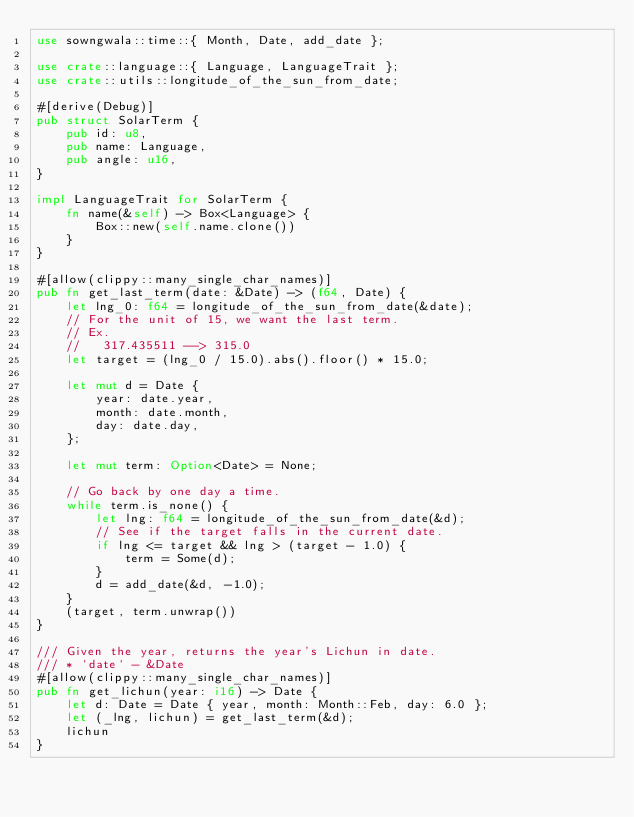Convert code to text. <code><loc_0><loc_0><loc_500><loc_500><_Rust_>use sowngwala::time::{ Month, Date, add_date };

use crate::language::{ Language, LanguageTrait };
use crate::utils::longitude_of_the_sun_from_date;

#[derive(Debug)]
pub struct SolarTerm {
    pub id: u8,
    pub name: Language,
    pub angle: u16,
}

impl LanguageTrait for SolarTerm {
    fn name(&self) -> Box<Language> {
        Box::new(self.name.clone())
    }
}

#[allow(clippy::many_single_char_names)]
pub fn get_last_term(date: &Date) -> (f64, Date) {
    let lng_0: f64 = longitude_of_the_sun_from_date(&date);
    // For the unit of 15, we want the last term.
    // Ex.
    //   317.435511 --> 315.0
    let target = (lng_0 / 15.0).abs().floor() * 15.0;

    let mut d = Date {
        year: date.year,
        month: date.month,
        day: date.day,
    };

    let mut term: Option<Date> = None;

    // Go back by one day a time.
    while term.is_none() {
        let lng: f64 = longitude_of_the_sun_from_date(&d);
        // See if the target falls in the current date.
        if lng <= target && lng > (target - 1.0) {
            term = Some(d);
        }
        d = add_date(&d, -1.0);
    }
    (target, term.unwrap())
}

/// Given the year, returns the year's Lichun in date.
/// * `date` - &Date
#[allow(clippy::many_single_char_names)]
pub fn get_lichun(year: i16) -> Date {
    let d: Date = Date { year, month: Month::Feb, day: 6.0 };
    let (_lng, lichun) = get_last_term(&d);
    lichun
}
</code> 